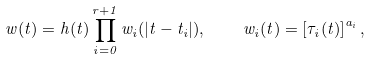<formula> <loc_0><loc_0><loc_500><loc_500>w ( t ) = h ( t ) \prod _ { i = 0 } ^ { r + 1 } w _ { i } ( | t - t _ { i } | ) , \quad w _ { i } ( t ) = \left [ \tau _ { i } ( t ) \right ] ^ { a _ { i } } ,</formula> 